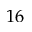<formula> <loc_0><loc_0><loc_500><loc_500>1 6</formula> 